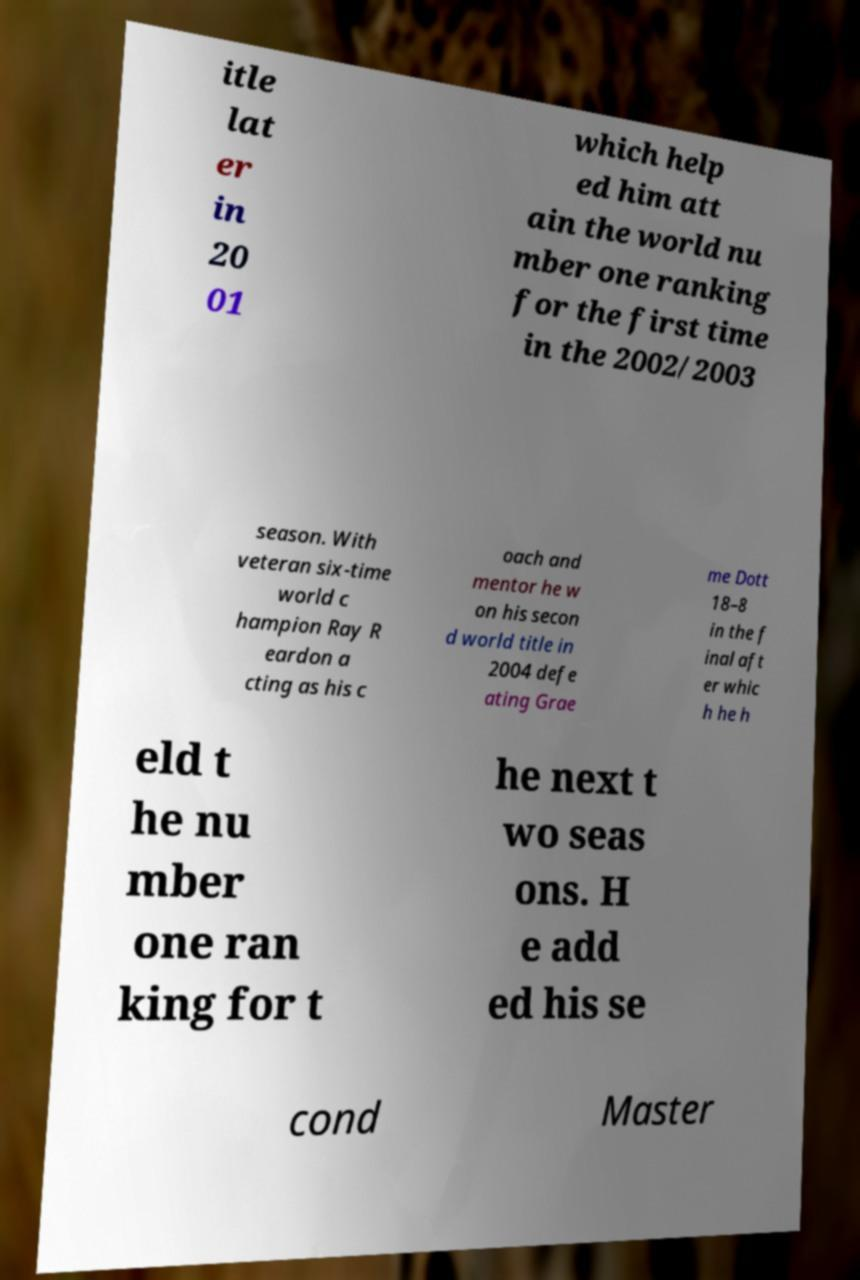For documentation purposes, I need the text within this image transcribed. Could you provide that? itle lat er in 20 01 which help ed him att ain the world nu mber one ranking for the first time in the 2002/2003 season. With veteran six-time world c hampion Ray R eardon a cting as his c oach and mentor he w on his secon d world title in 2004 defe ating Grae me Dott 18–8 in the f inal aft er whic h he h eld t he nu mber one ran king for t he next t wo seas ons. H e add ed his se cond Master 